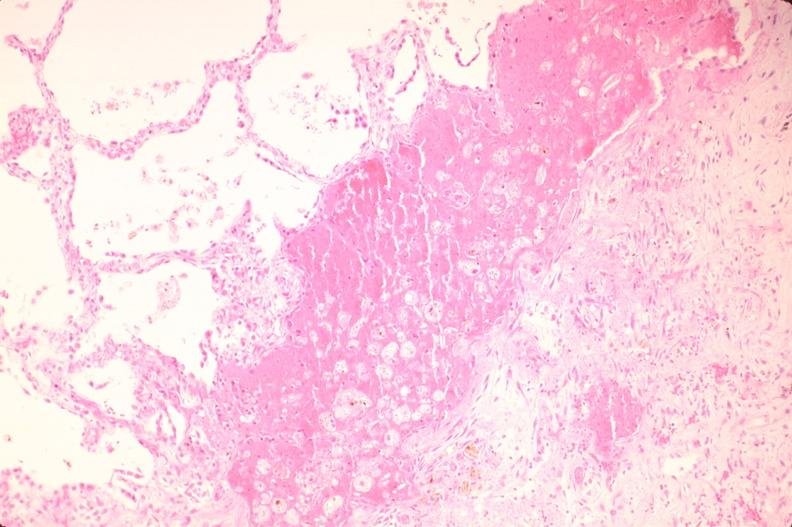where is this?
Answer the question using a single word or phrase. Lung 